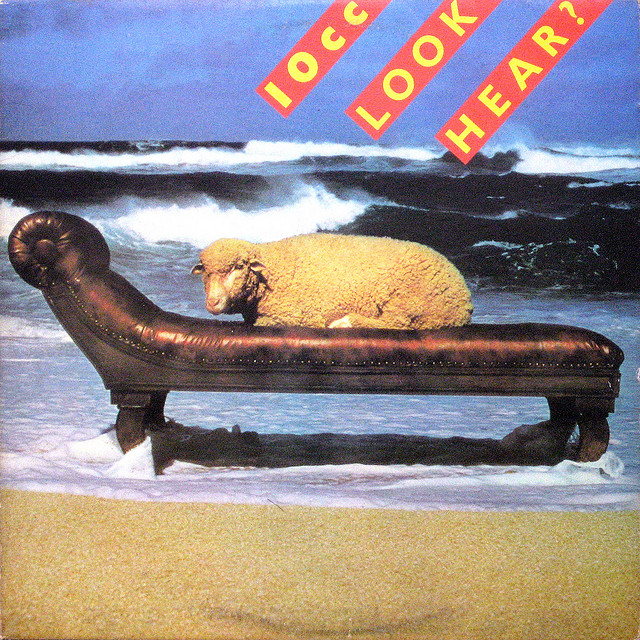Read and extract the text from this image. LOOK HEAR? IOCC 